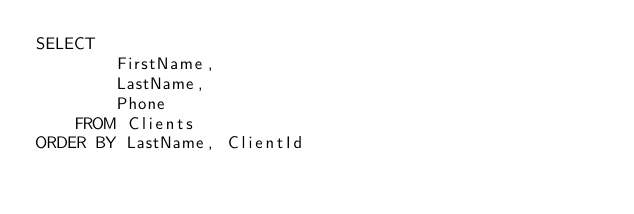<code> <loc_0><loc_0><loc_500><loc_500><_SQL_>SELECT
		FirstName,
		LastName,
		Phone
	FROM Clients
ORDER BY LastName, ClientId</code> 